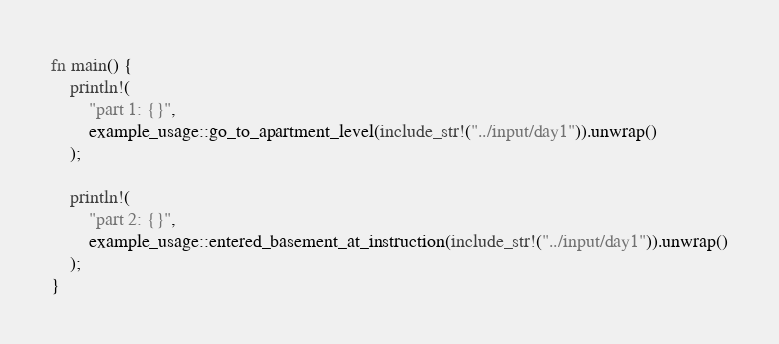<code> <loc_0><loc_0><loc_500><loc_500><_Rust_>fn main() {
    println!(
        "part 1: {}",
        example_usage::go_to_apartment_level(include_str!("../input/day1")).unwrap()
    );

    println!(
        "part 2: {}",
        example_usage::entered_basement_at_instruction(include_str!("../input/day1")).unwrap()
    );
}
</code> 